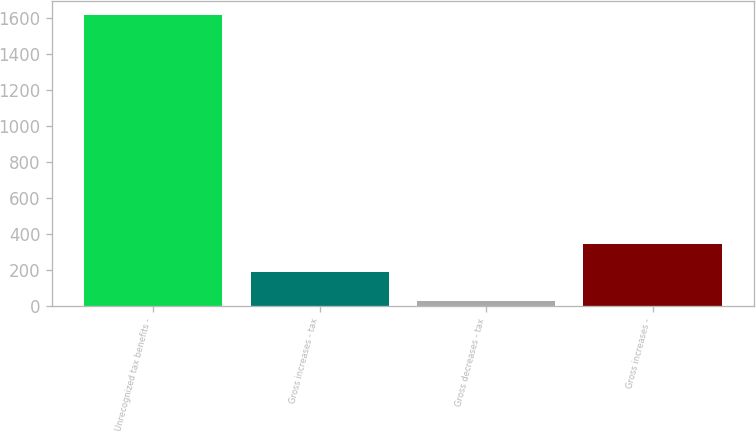Convert chart to OTSL. <chart><loc_0><loc_0><loc_500><loc_500><bar_chart><fcel>Unrecognized tax benefits -<fcel>Gross increases - tax<fcel>Gross decreases - tax<fcel>Gross increases -<nl><fcel>1617<fcel>184.2<fcel>25<fcel>343.4<nl></chart> 